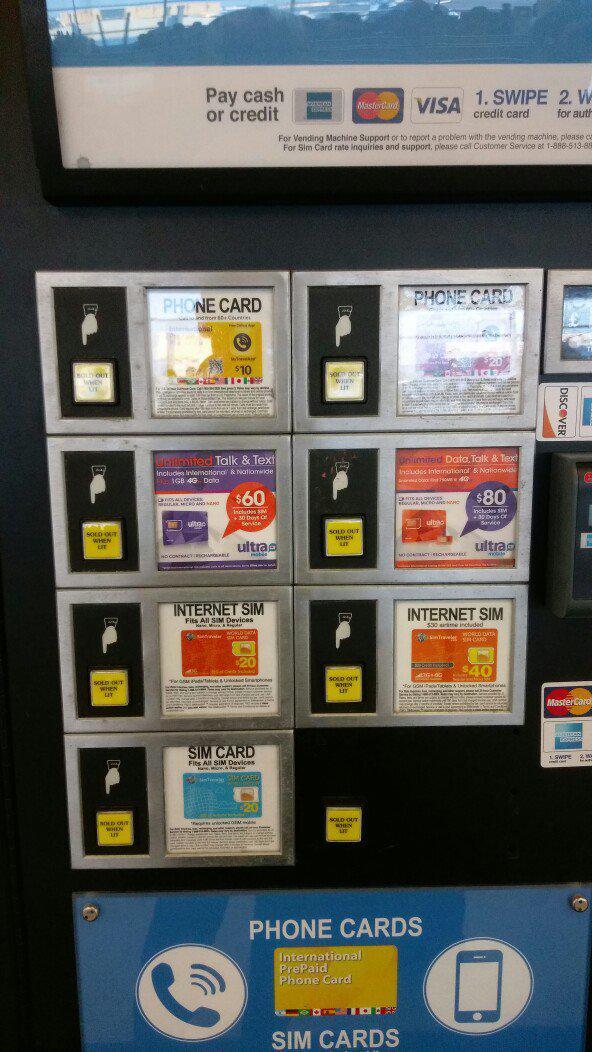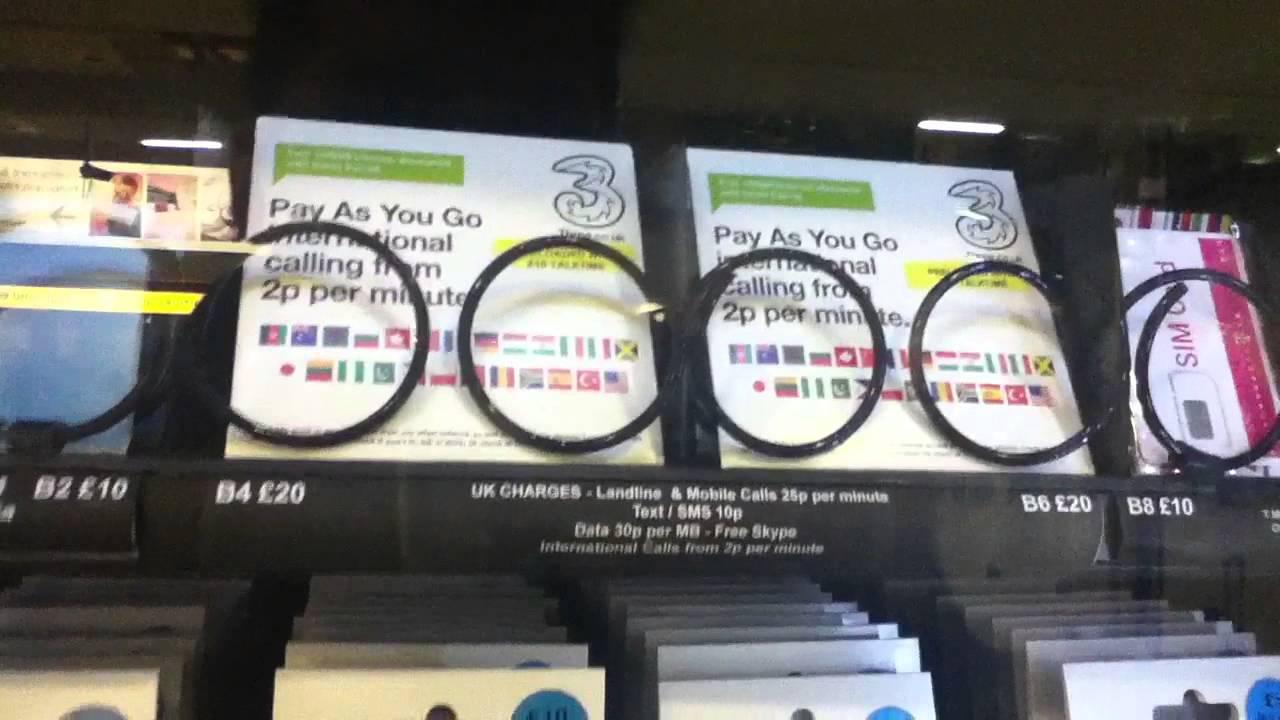The first image is the image on the left, the second image is the image on the right. For the images shown, is this caption "There is a single Sim card vending  with a large blue sign set against a white wall." true? Answer yes or no. No. The first image is the image on the left, the second image is the image on the right. Considering the images on both sides, is "You can clearly see that the vending machine on the left is up against a solid wall." valid? Answer yes or no. No. 